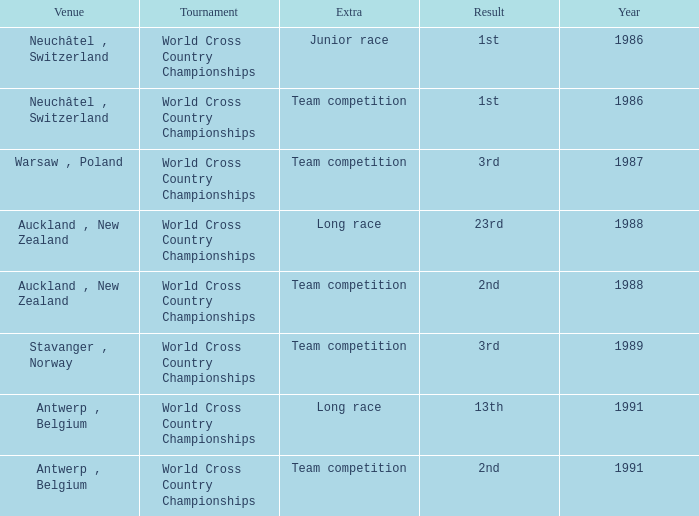Which venue had an extra of Team Competition and a result of 1st? Neuchâtel , Switzerland. 